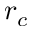Convert formula to latex. <formula><loc_0><loc_0><loc_500><loc_500>r _ { c }</formula> 